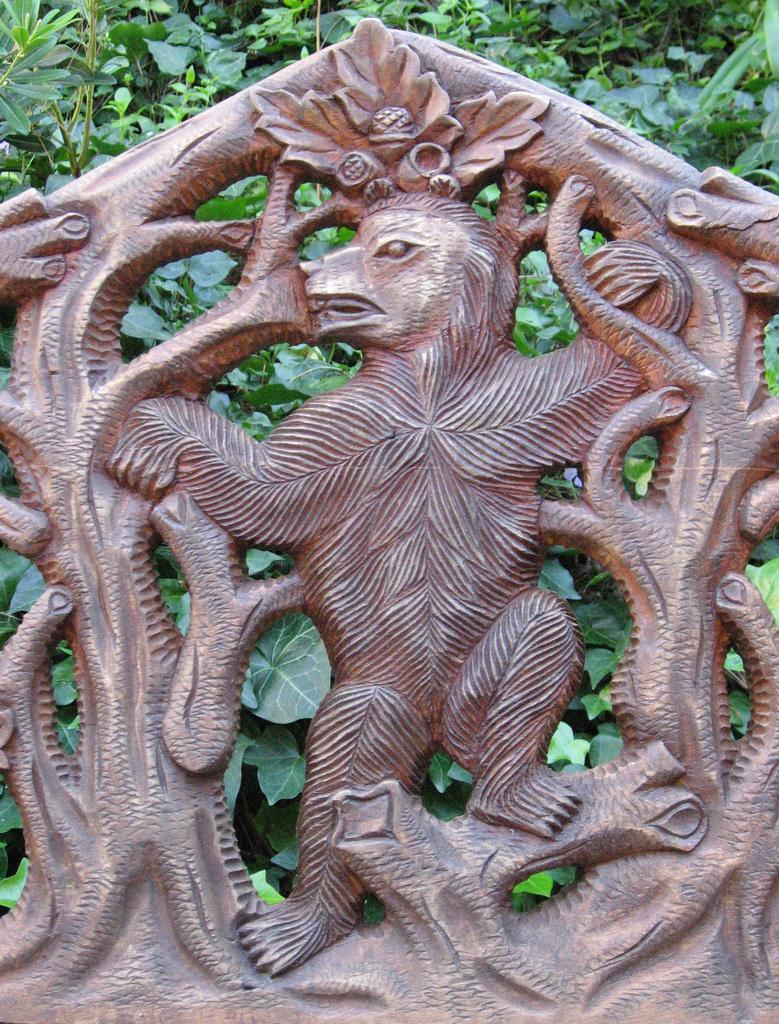In one or two sentences, can you explain what this image depicts? In this image there is a sculpture, in the background there are plants. 